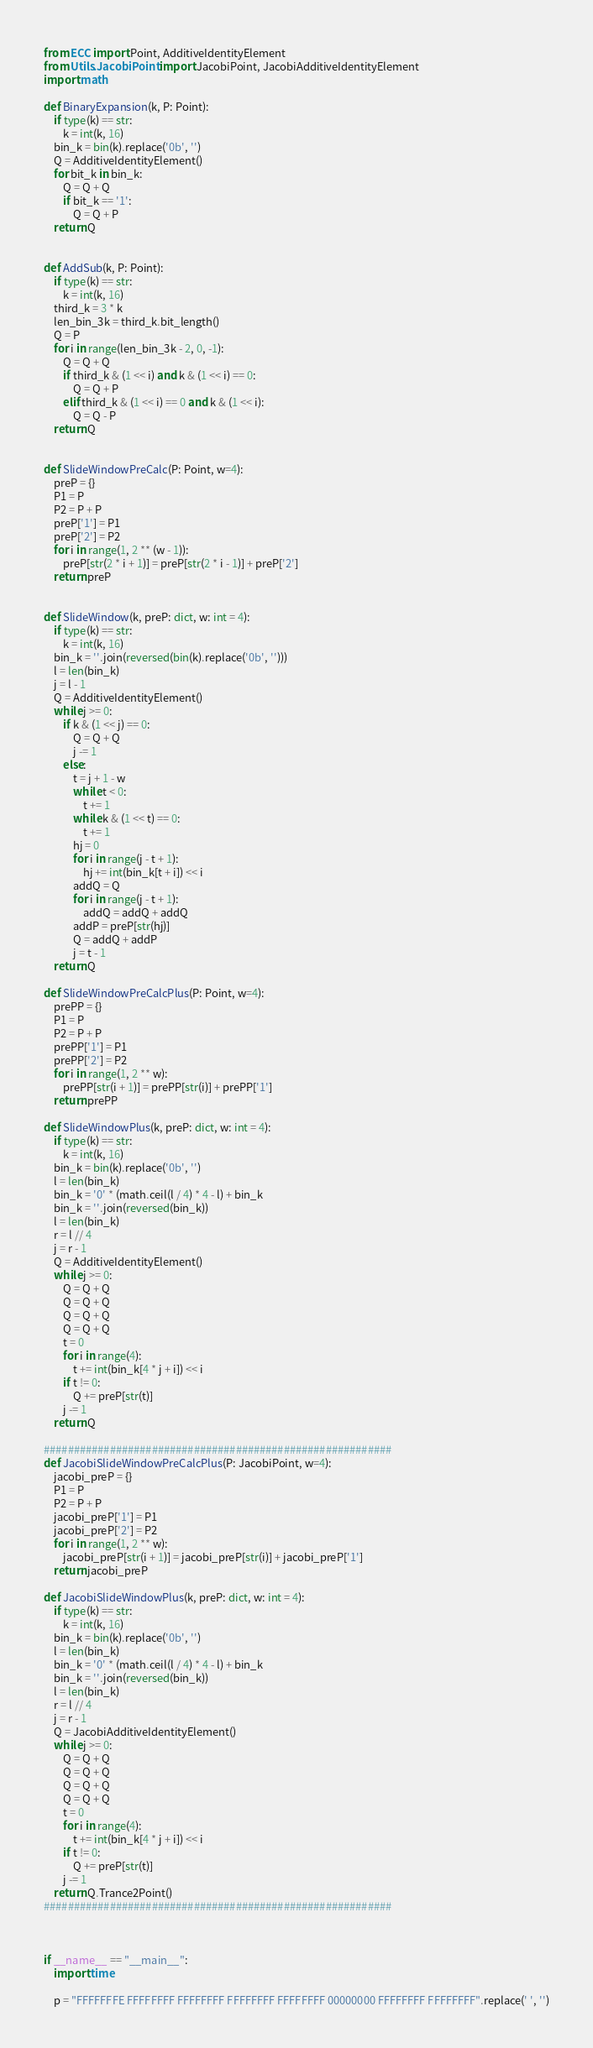<code> <loc_0><loc_0><loc_500><loc_500><_Python_>from ECC import Point, AdditiveIdentityElement
from Utils.JacobiPoint import JacobiPoint, JacobiAdditiveIdentityElement
import math

def BinaryExpansion(k, P: Point):
    if type(k) == str:
        k = int(k, 16)
    bin_k = bin(k).replace('0b', '')
    Q = AdditiveIdentityElement()
    for bit_k in bin_k:
        Q = Q + Q
        if bit_k == '1':
            Q = Q + P
    return Q


def AddSub(k, P: Point):
    if type(k) == str:
        k = int(k, 16)
    third_k = 3 * k
    len_bin_3k = third_k.bit_length()
    Q = P
    for i in range(len_bin_3k - 2, 0, -1):
        Q = Q + Q
        if third_k & (1 << i) and k & (1 << i) == 0:
            Q = Q + P
        elif third_k & (1 << i) == 0 and k & (1 << i):
            Q = Q - P
    return Q


def SlideWindowPreCalc(P: Point, w=4):
    preP = {}
    P1 = P
    P2 = P + P
    preP['1'] = P1
    preP['2'] = P2
    for i in range(1, 2 ** (w - 1)):
        preP[str(2 * i + 1)] = preP[str(2 * i - 1)] + preP['2']
    return preP


def SlideWindow(k, preP: dict, w: int = 4):
    if type(k) == str:
        k = int(k, 16)
    bin_k = ''.join(reversed(bin(k).replace('0b', '')))
    l = len(bin_k)
    j = l - 1
    Q = AdditiveIdentityElement()
    while j >= 0:
        if k & (1 << j) == 0:
            Q = Q + Q
            j -= 1
        else:
            t = j + 1 - w
            while t < 0:
                t += 1
            while k & (1 << t) == 0:
                t += 1
            hj = 0
            for i in range(j - t + 1):
                hj += int(bin_k[t + i]) << i
            addQ = Q
            for i in range(j - t + 1):
                addQ = addQ + addQ
            addP = preP[str(hj)]
            Q = addQ + addP
            j = t - 1
    return Q

def SlideWindowPreCalcPlus(P: Point, w=4):
    prePP = {}
    P1 = P
    P2 = P + P
    prePP['1'] = P1
    prePP['2'] = P2
    for i in range(1, 2 ** w):
        prePP[str(i + 1)] = prePP[str(i)] + prePP['1']
    return prePP

def SlideWindowPlus(k, preP: dict, w: int = 4):
    if type(k) == str:
        k = int(k, 16)
    bin_k = bin(k).replace('0b', '')
    l = len(bin_k)
    bin_k = '0' * (math.ceil(l / 4) * 4 - l) + bin_k
    bin_k = ''.join(reversed(bin_k))
    l = len(bin_k)
    r = l // 4
    j = r - 1
    Q = AdditiveIdentityElement()
    while j >= 0:
        Q = Q + Q
        Q = Q + Q
        Q = Q + Q
        Q = Q + Q
        t = 0
        for i in range(4):
            t += int(bin_k[4 * j + i]) << i
        if t != 0:
            Q += preP[str(t)]
        j -= 1
    return Q

##########################################################
def JacobiSlideWindowPreCalcPlus(P: JacobiPoint, w=4):
    jacobi_preP = {}
    P1 = P
    P2 = P + P
    jacobi_preP['1'] = P1
    jacobi_preP['2'] = P2
    for i in range(1, 2 ** w):
        jacobi_preP[str(i + 1)] = jacobi_preP[str(i)] + jacobi_preP['1']
    return jacobi_preP

def JacobiSlideWindowPlus(k, preP: dict, w: int = 4):
    if type(k) == str:
        k = int(k, 16)
    bin_k = bin(k).replace('0b', '')
    l = len(bin_k)
    bin_k = '0' * (math.ceil(l / 4) * 4 - l) + bin_k
    bin_k = ''.join(reversed(bin_k))
    l = len(bin_k)
    r = l // 4
    j = r - 1
    Q = JacobiAdditiveIdentityElement()
    while j >= 0:
        Q = Q + Q
        Q = Q + Q
        Q = Q + Q
        Q = Q + Q
        t = 0
        for i in range(4):
            t += int(bin_k[4 * j + i]) << i
        if t != 0:
            Q += preP[str(t)]
        j -= 1
    return Q.Trance2Point()
##########################################################



if __name__ == "__main__":
    import time

    p = "FFFFFFFE FFFFFFFF FFFFFFFF FFFFFFFF FFFFFFFF 00000000 FFFFFFFF FFFFFFFF".replace(' ', '')</code> 